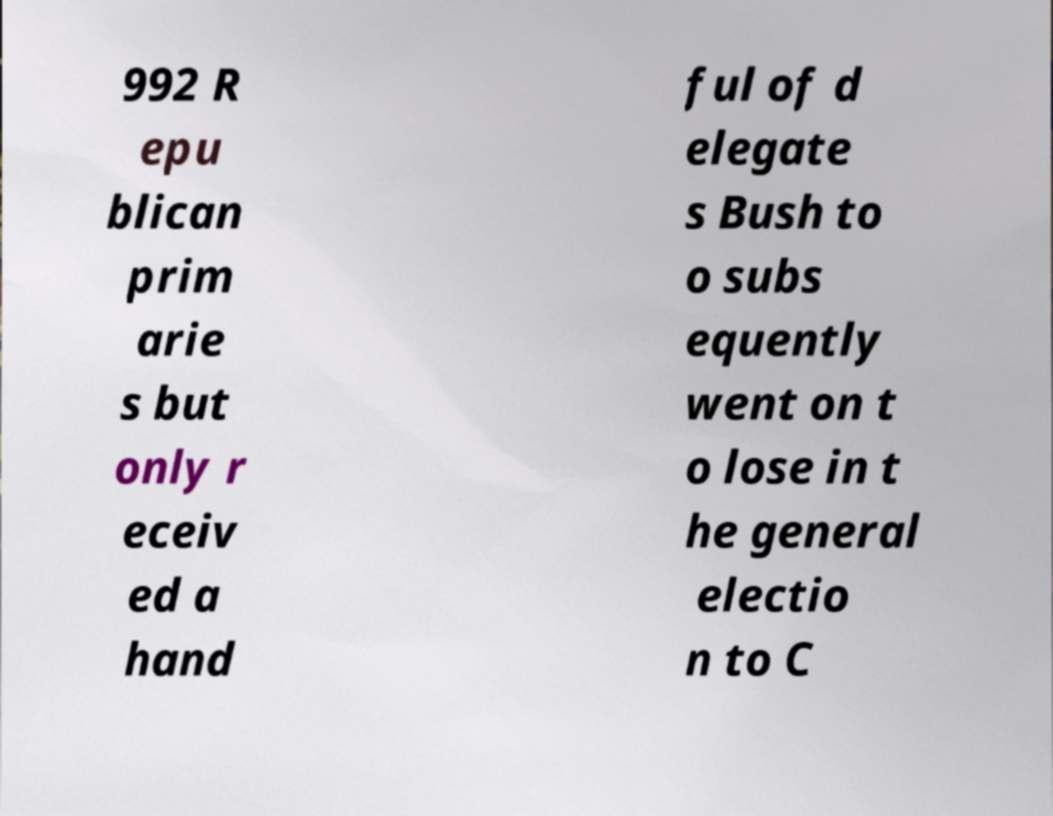Could you assist in decoding the text presented in this image and type it out clearly? 992 R epu blican prim arie s but only r eceiv ed a hand ful of d elegate s Bush to o subs equently went on t o lose in t he general electio n to C 